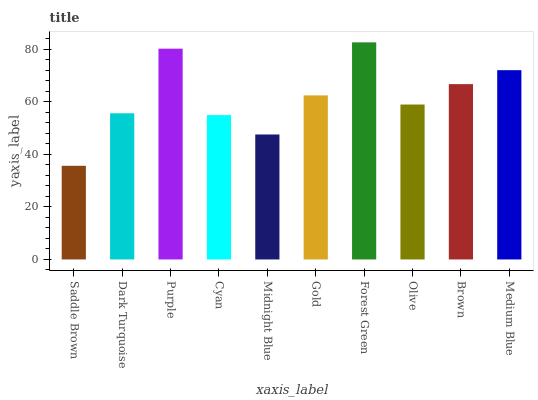Is Saddle Brown the minimum?
Answer yes or no. Yes. Is Forest Green the maximum?
Answer yes or no. Yes. Is Dark Turquoise the minimum?
Answer yes or no. No. Is Dark Turquoise the maximum?
Answer yes or no. No. Is Dark Turquoise greater than Saddle Brown?
Answer yes or no. Yes. Is Saddle Brown less than Dark Turquoise?
Answer yes or no. Yes. Is Saddle Brown greater than Dark Turquoise?
Answer yes or no. No. Is Dark Turquoise less than Saddle Brown?
Answer yes or no. No. Is Gold the high median?
Answer yes or no. Yes. Is Olive the low median?
Answer yes or no. Yes. Is Dark Turquoise the high median?
Answer yes or no. No. Is Gold the low median?
Answer yes or no. No. 